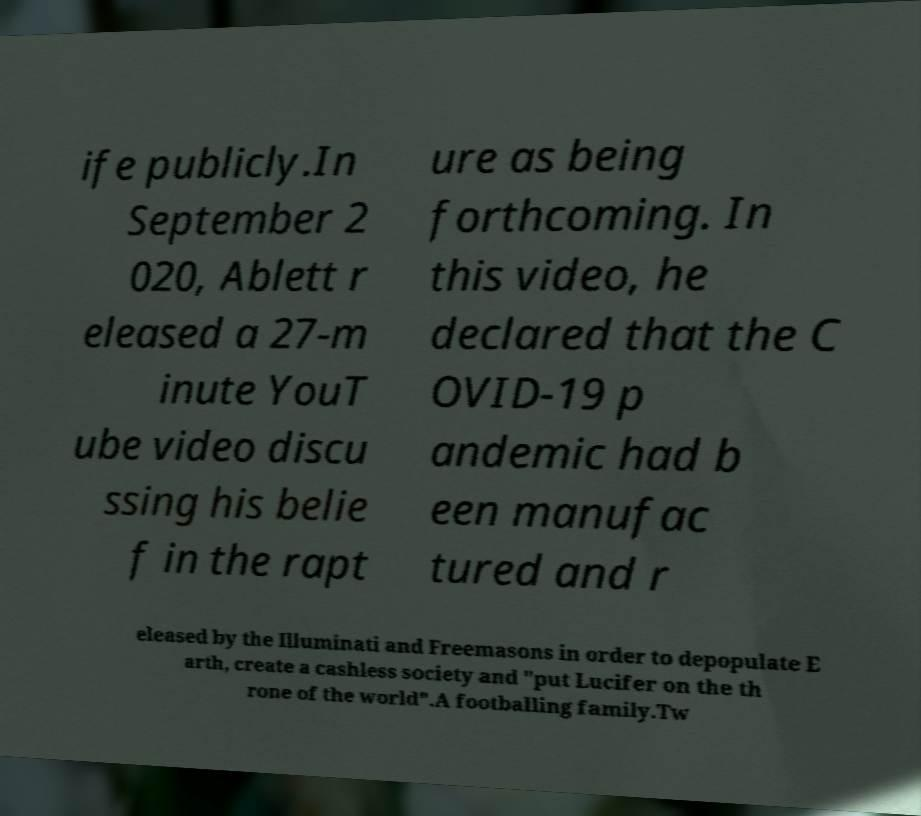Could you assist in decoding the text presented in this image and type it out clearly? ife publicly.In September 2 020, Ablett r eleased a 27-m inute YouT ube video discu ssing his belie f in the rapt ure as being forthcoming. In this video, he declared that the C OVID-19 p andemic had b een manufac tured and r eleased by the Illuminati and Freemasons in order to depopulate E arth, create a cashless society and "put Lucifer on the th rone of the world".A footballing family.Tw 